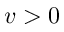Convert formula to latex. <formula><loc_0><loc_0><loc_500><loc_500>v > 0</formula> 